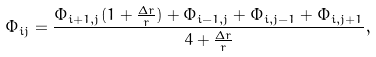Convert formula to latex. <formula><loc_0><loc_0><loc_500><loc_500>\Phi _ { i j } = \frac { \Phi _ { i + 1 , j } ( 1 + \frac { \Delta r } { r } ) + \Phi _ { i - 1 , j } + \Phi _ { i , j - 1 } + \Phi _ { i , j + 1 } } { 4 + \frac { \Delta r } { r } } ,</formula> 